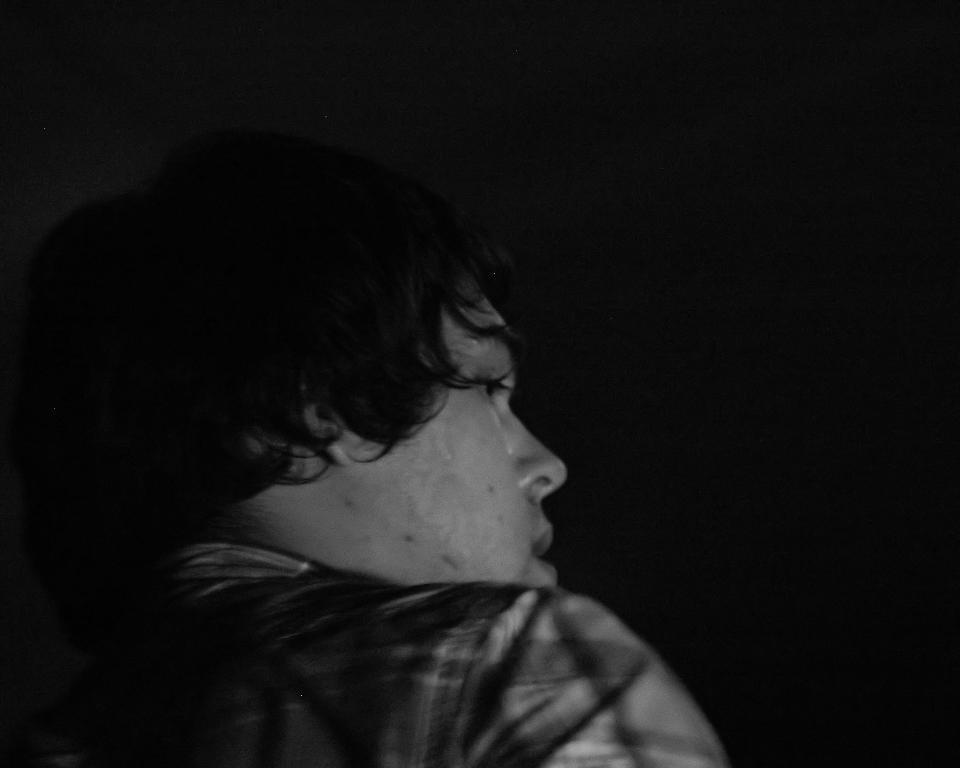Can you describe this image briefly? As we can see in the image there is a man wearing black color shirt and the image is little dark. 